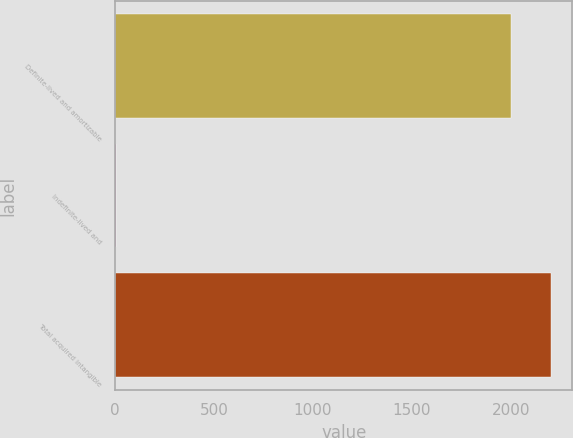Convert chart. <chart><loc_0><loc_0><loc_500><loc_500><bar_chart><fcel>Definite-lived and amortizable<fcel>Indefinite-lived and<fcel>Total acquired intangible<nl><fcel>2002<fcel>3.01<fcel>2201.9<nl></chart> 